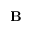<formula> <loc_0><loc_0><loc_500><loc_500>B</formula> 